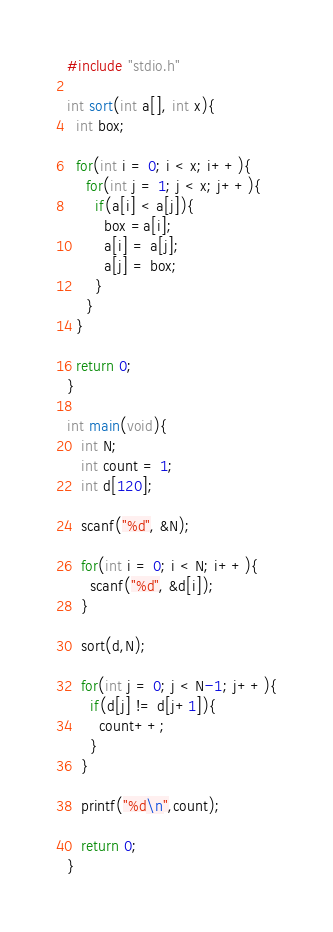Convert code to text. <code><loc_0><loc_0><loc_500><loc_500><_C_>#include "stdio.h"

int sort(int a[], int x){
  int box;

  for(int i = 0; i < x; i++){
    for(int j = 1; j < x; j++){
      if(a[i] < a[j]){
        box =a[i];
        a[i] = a[j];
        a[j] = box;
      }
    }
  }

  return 0;
}

int main(void){
   int N;
   int count = 1;
   int d[120];

   scanf("%d", &N);

   for(int i = 0; i < N; i++){
     scanf("%d", &d[i]);
   }

   sort(d,N);

   for(int j = 0; j < N-1; j++){
     if(d[j] != d[j+1]){
       count++;
     }
   }

   printf("%d\n",count);

   return 0;
}
</code> 